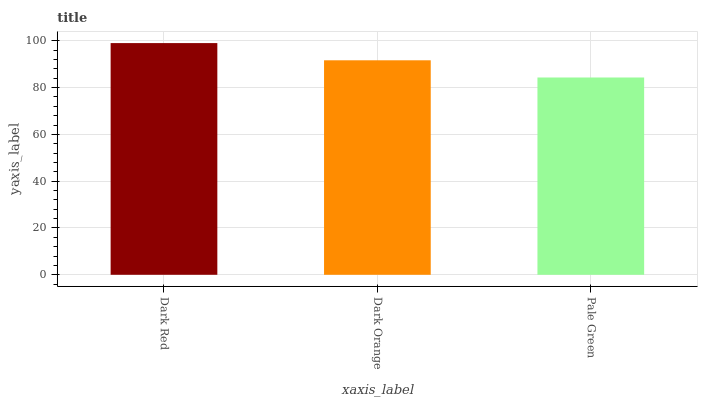Is Dark Orange the minimum?
Answer yes or no. No. Is Dark Orange the maximum?
Answer yes or no. No. Is Dark Red greater than Dark Orange?
Answer yes or no. Yes. Is Dark Orange less than Dark Red?
Answer yes or no. Yes. Is Dark Orange greater than Dark Red?
Answer yes or no. No. Is Dark Red less than Dark Orange?
Answer yes or no. No. Is Dark Orange the high median?
Answer yes or no. Yes. Is Dark Orange the low median?
Answer yes or no. Yes. Is Dark Red the high median?
Answer yes or no. No. Is Pale Green the low median?
Answer yes or no. No. 